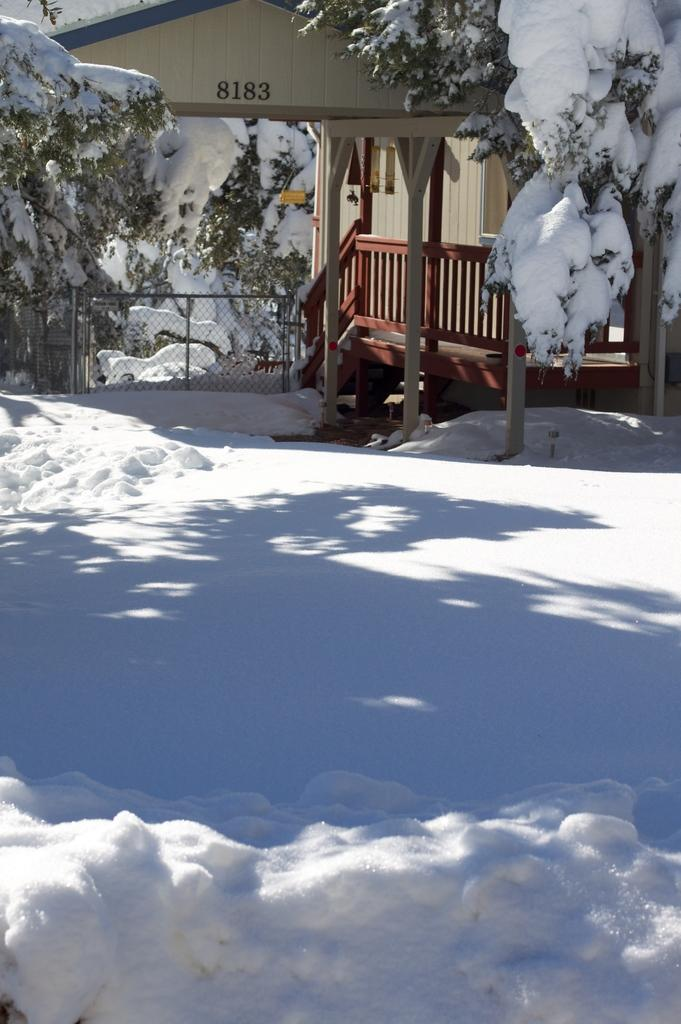What type of weather is depicted in the image? There is snow at the bottom of the image, indicating a winter scene. What can be seen in the background of the image? There is a house and trees in the background of the image. How are the trees affected by the weather? The trees are covered with snow in the image. What other objects are present in the image? There are wooden poles in the image. Where is the sofa located in the image? There is no sofa present in the image. What type of drink is being served in the image? There is no drink being served in the image. 